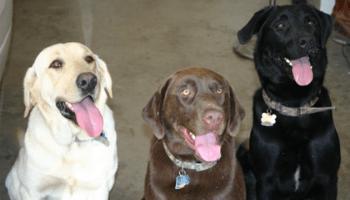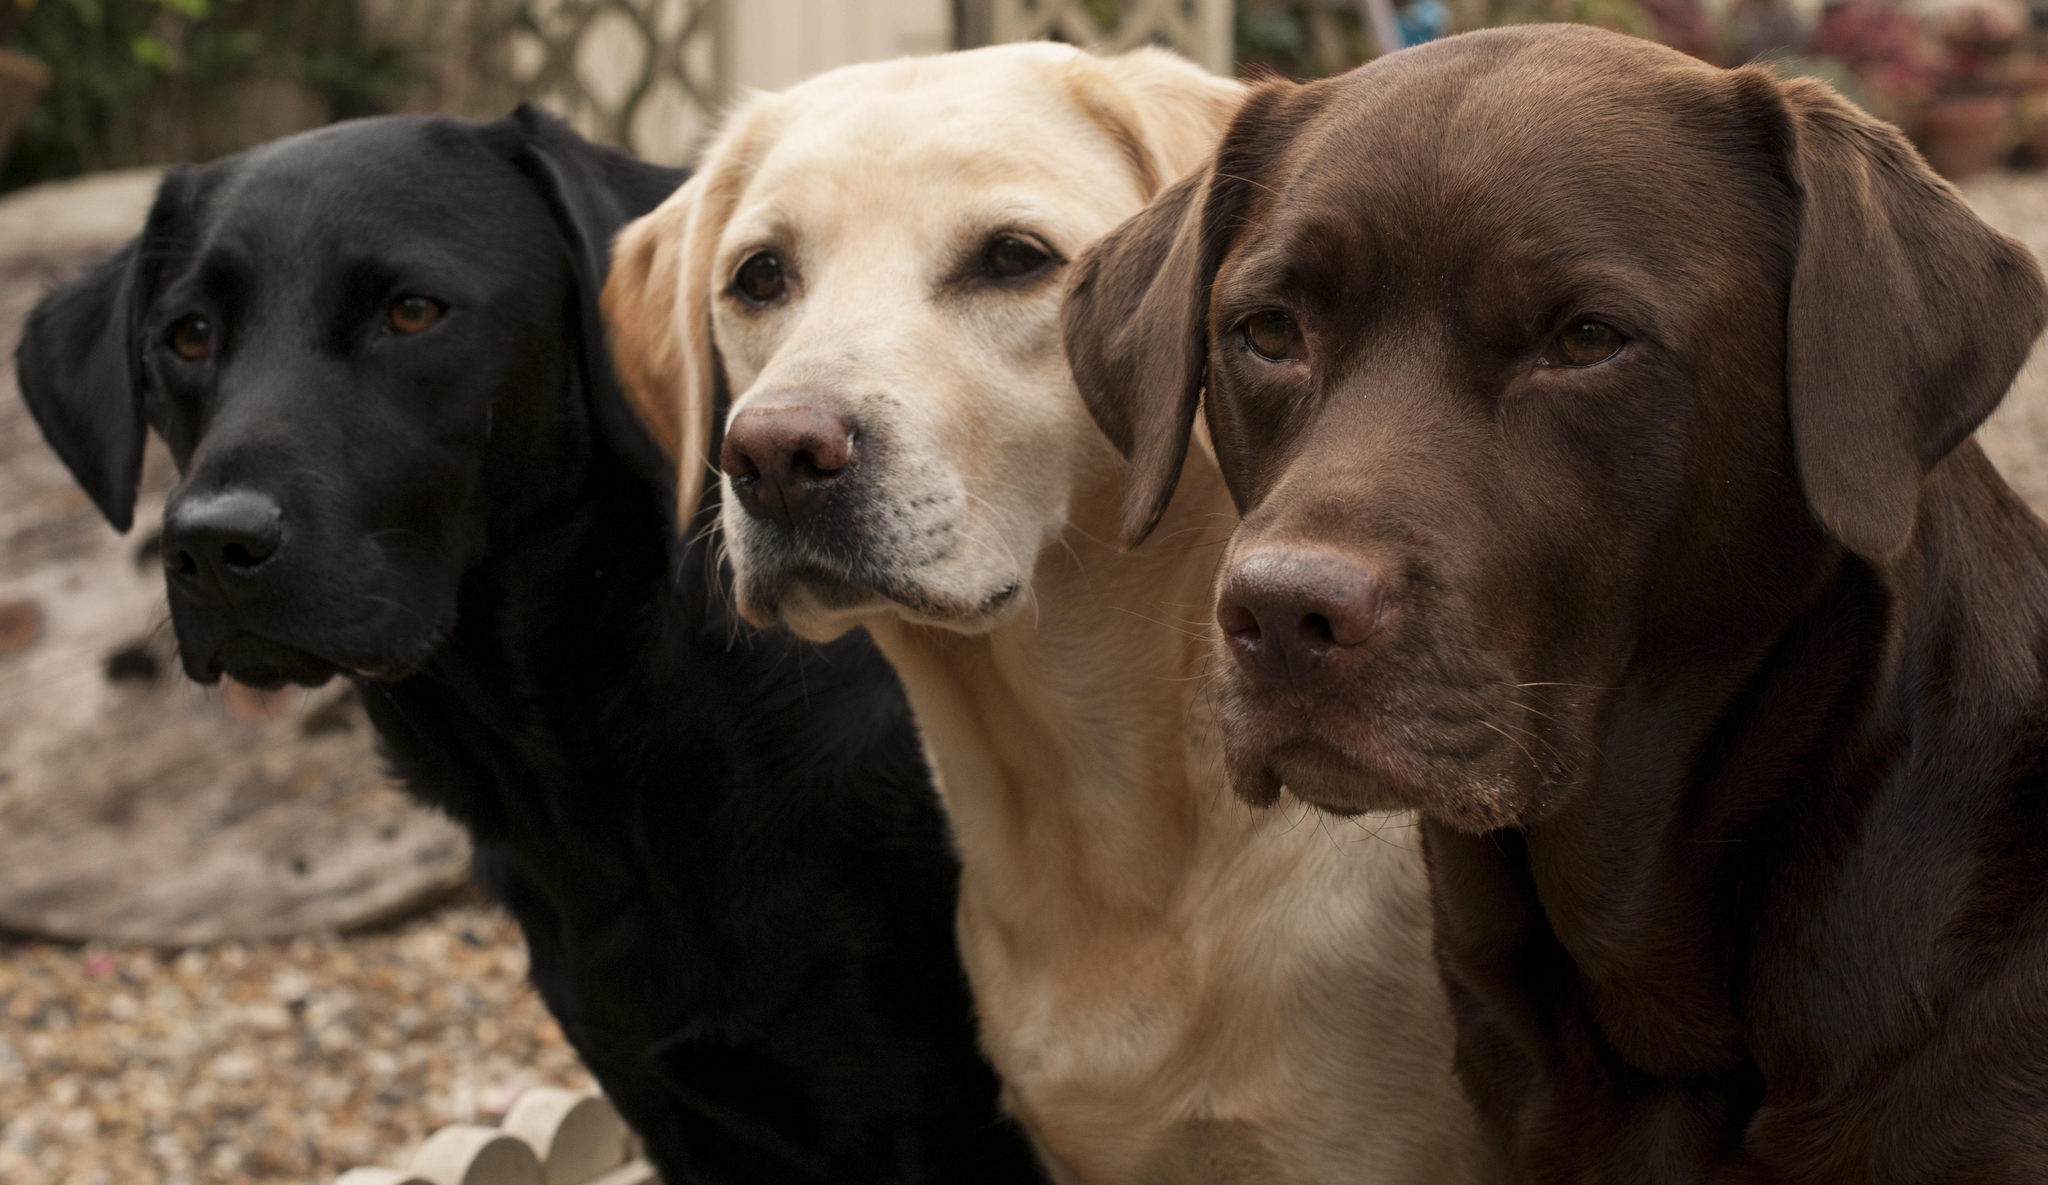The first image is the image on the left, the second image is the image on the right. Analyze the images presented: Is the assertion "There are three labs posing together in each image." valid? Answer yes or no. Yes. The first image is the image on the left, the second image is the image on the right. Given the left and right images, does the statement "Both images contain exactly three dogs, and include at least one image of all different colored dogs." hold true? Answer yes or no. Yes. 